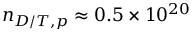<formula> <loc_0><loc_0><loc_500><loc_500>n _ { D / T , p } \approx 0 . 5 \times 1 0 ^ { 2 0 }</formula> 